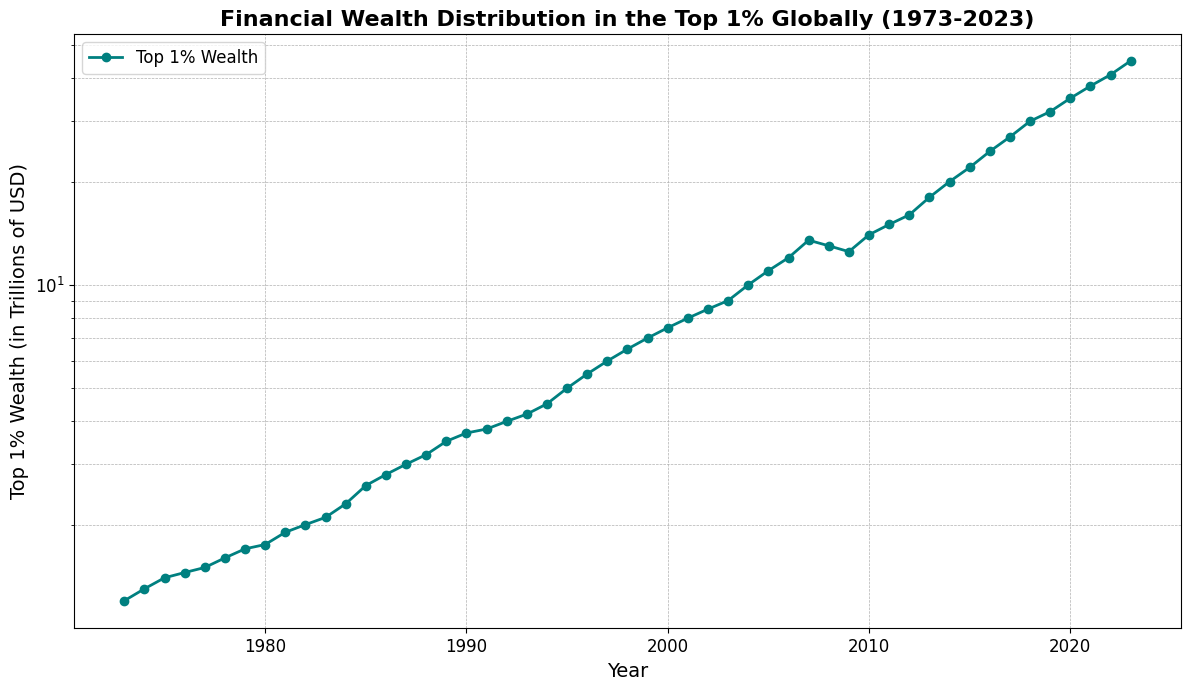What is the general trend of the top 1% wealth from 1973 to 2023? From the figure, the line representing the top 1% wealth generally increases over time, showing exponential growth especially noticeable towards the last few decades. The application of the log scale emphasizes the increase in magnitude over time.
Answer: Increasing What is the difference in the top 1% wealth between 2000 and 2020? According to the figure, the top 1% wealth in 2000 was 7.5 trillion USD and in 2020 it was 35 trillion USD. The difference is 35 - 7.5 = 27.5 trillion USD.
Answer: 27.5 trillion USD During which period did the top 1% wealth grow the fastest? The significant increase in the slope of the curve on the log scale especially between 2010 and 2023 indicates the fastest growth period. The visual steepness in this timeframe is evident.
Answer: 2010-2023 How did the financial crisis of 2008 affect the wealth distribution of the top 1%? The wealth decreased from 13.5 trillion USD in 2007 to 13 trillion USD in 2008 and further declined to 12.5 trillion USD in 2009. This indicates a negative impact during the crisis.
Answer: It decreased How much did the top 1% wealth increase from 1995 to 2005? In 1995, the top 1% wealth was 5 trillion USD, and by 2005 it was 11 trillion USD. The increase is 11 - 5 = 6 trillion USD.
Answer: 6 trillion USD In what year did the top 1% wealth reach 10 trillion USD? The figure shows that the top 1% wealth reached 10 trillion USD in 2004.
Answer: 2004 Which year showed the first significant decline in wealth after a steady increase? After a steady increase, the first significant decline is seen in 2008, from 13.5 trillion USD in 2007 to 13 trillion USD in 2008.
Answer: 2008 By how much did the wealth of the top 1% increase in the first 10 years (1973-1983)? In 1973, the wealth was 1.2 trillion USD and in 1983 it was 2.1 trillion USD. The increase is 2.1 - 1.2 = 0.9 trillion USD.
Answer: 0.9 trillion USD Compare the wealth of the top 1% in 1990 and 2000. Which year had higher wealth and by how much? The wealth in 1990 was 3.7 trillion USD and in 2000 it was 7.5 trillion USD. 2000 had higher wealth by 7.5 - 3.7 = 3.8 trillion USD.
Answer: 2000, by 3.8 trillion USD 